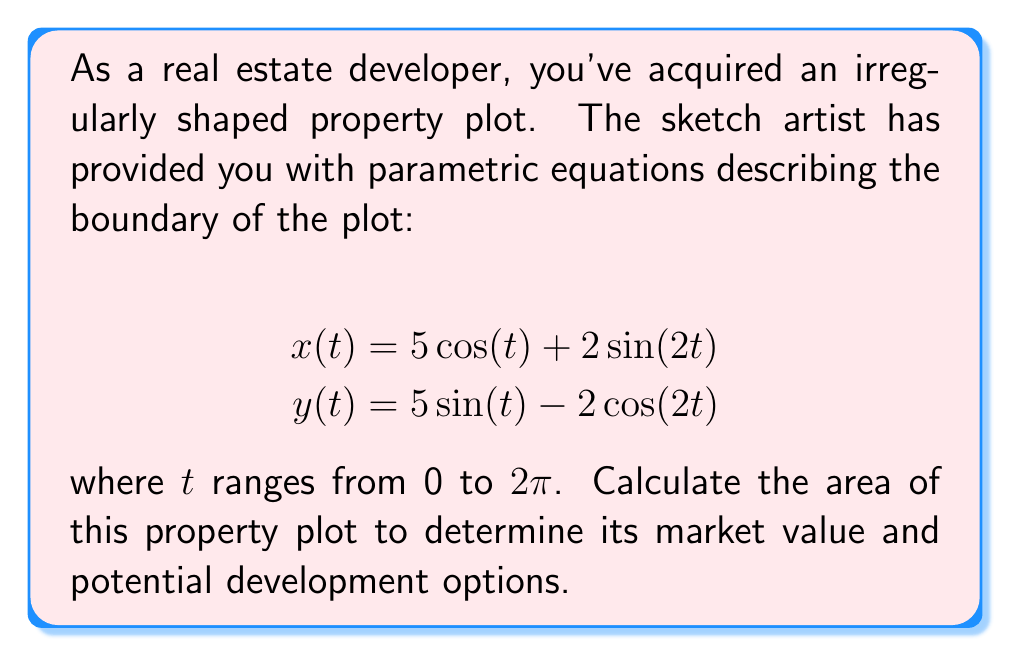Teach me how to tackle this problem. To calculate the area of the irregularly shaped property plot described by parametric equations, we can use Green's theorem. The area enclosed by a parametric curve is given by:

$$A = \frac{1}{2} \int_0^{2\pi} [x(t)y'(t) - y(t)x'(t)] dt$$

Let's follow these steps:

1) First, we need to find $x'(t)$ and $y'(t)$:

   $$x'(t) = -5\sin(t) + 4\cos(2t)$$
   $$y'(t) = 5\cos(t) + 4\sin(2t)$$

2) Now, let's substitute these into our area formula:

   $$A = \frac{1}{2} \int_0^{2\pi} [(5\cos(t) + 2\sin(2t))(5\cos(t) + 4\sin(2t)) - (5\sin(t) - 2\cos(2t))(-5\sin(t) + 4\cos(2t))] dt$$

3) Expand the integrand:

   $$A = \frac{1}{2} \int_0^{2\pi} [25\cos^2(t) + 20\cos(t)\sin(2t) + 10\sin(2t)\cos(t) + 8\sin^2(2t) + 25\sin^2(t) - 20\sin(t)\cos(2t) - 10\cos(2t)\sin(t) + 8\cos^2(2t)] dt$$

4) Simplify using trigonometric identities:

   $$A = \frac{1}{2} \int_0^{2\pi} [25 + 30\cos(t)\sin(2t) - 30\sin(t)\cos(2t) + 8] dt$$

   $$A = \frac{1}{2} \int_0^{2\pi} [33 + 30(\cos(t)\sin(2t) - \sin(t)\cos(2t))] dt$$

5) The term $\cos(t)\sin(2t) - \sin(t)\cos(2t)$ simplifies to $\sin(t)$, so:

   $$A = \frac{1}{2} \int_0^{2\pi} [33 + 30\sin(t)] dt$$

6) Integrate:

   $$A = \frac{1}{2} [33t - 30\cos(t)]_0^{2\pi}$$

7) Evaluate the definite integral:

   $$A = \frac{1}{2} [(33 \cdot 2\pi - 30\cos(2\pi)) - (0 - 30\cos(0))]$$
   $$A = \frac{1}{2} [66\pi - 30 + 30]$$
   $$A = 33\pi$$

Therefore, the area of the property plot is $33\pi$ square units.
Answer: $33\pi$ square units 